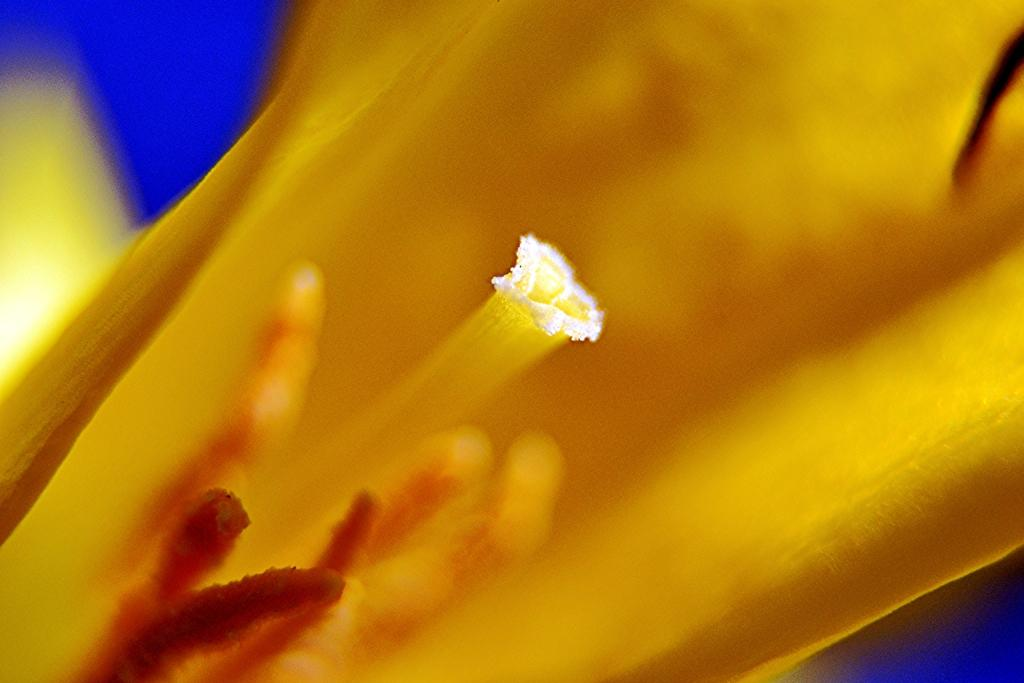What is the main color of the object in the image? The main color of the object in the image is yellow. What color is the background of the image? The background of the image is blue. Can you see any snails in the image? There are no snails present in the image. What type of trousers is the person wearing in the image? There is no person or trousers visible in the image. 